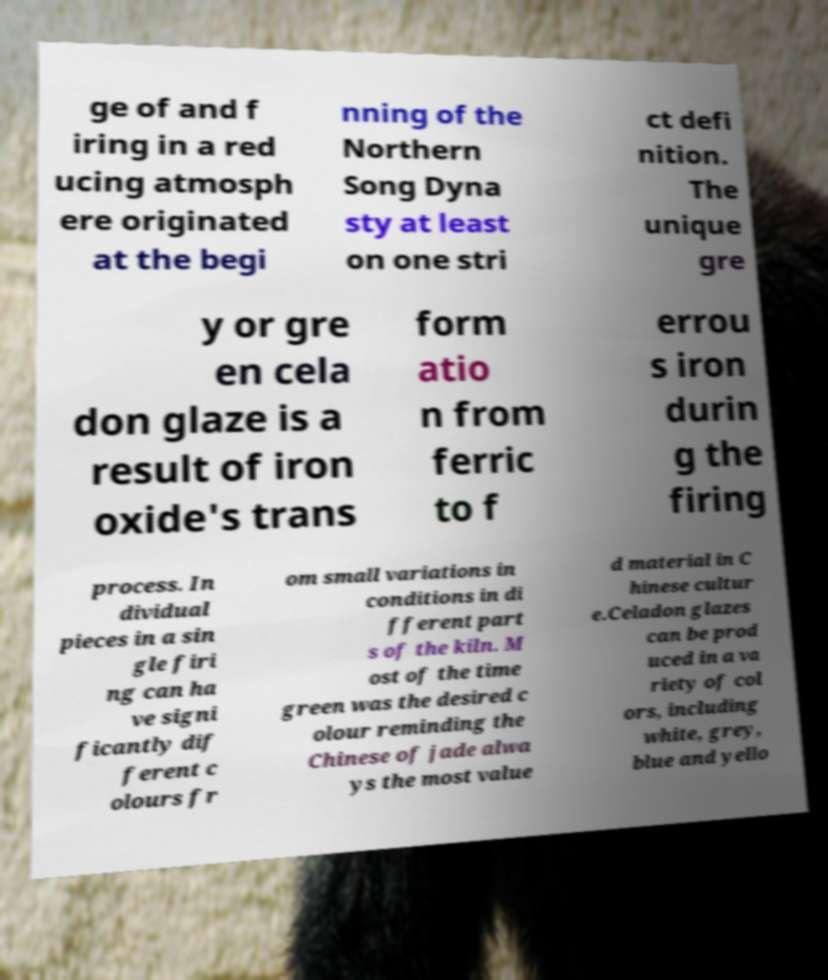Could you assist in decoding the text presented in this image and type it out clearly? ge of and f iring in a red ucing atmosph ere originated at the begi nning of the Northern Song Dyna sty at least on one stri ct defi nition. The unique gre y or gre en cela don glaze is a result of iron oxide's trans form atio n from ferric to f errou s iron durin g the firing process. In dividual pieces in a sin gle firi ng can ha ve signi ficantly dif ferent c olours fr om small variations in conditions in di fferent part s of the kiln. M ost of the time green was the desired c olour reminding the Chinese of jade alwa ys the most value d material in C hinese cultur e.Celadon glazes can be prod uced in a va riety of col ors, including white, grey, blue and yello 